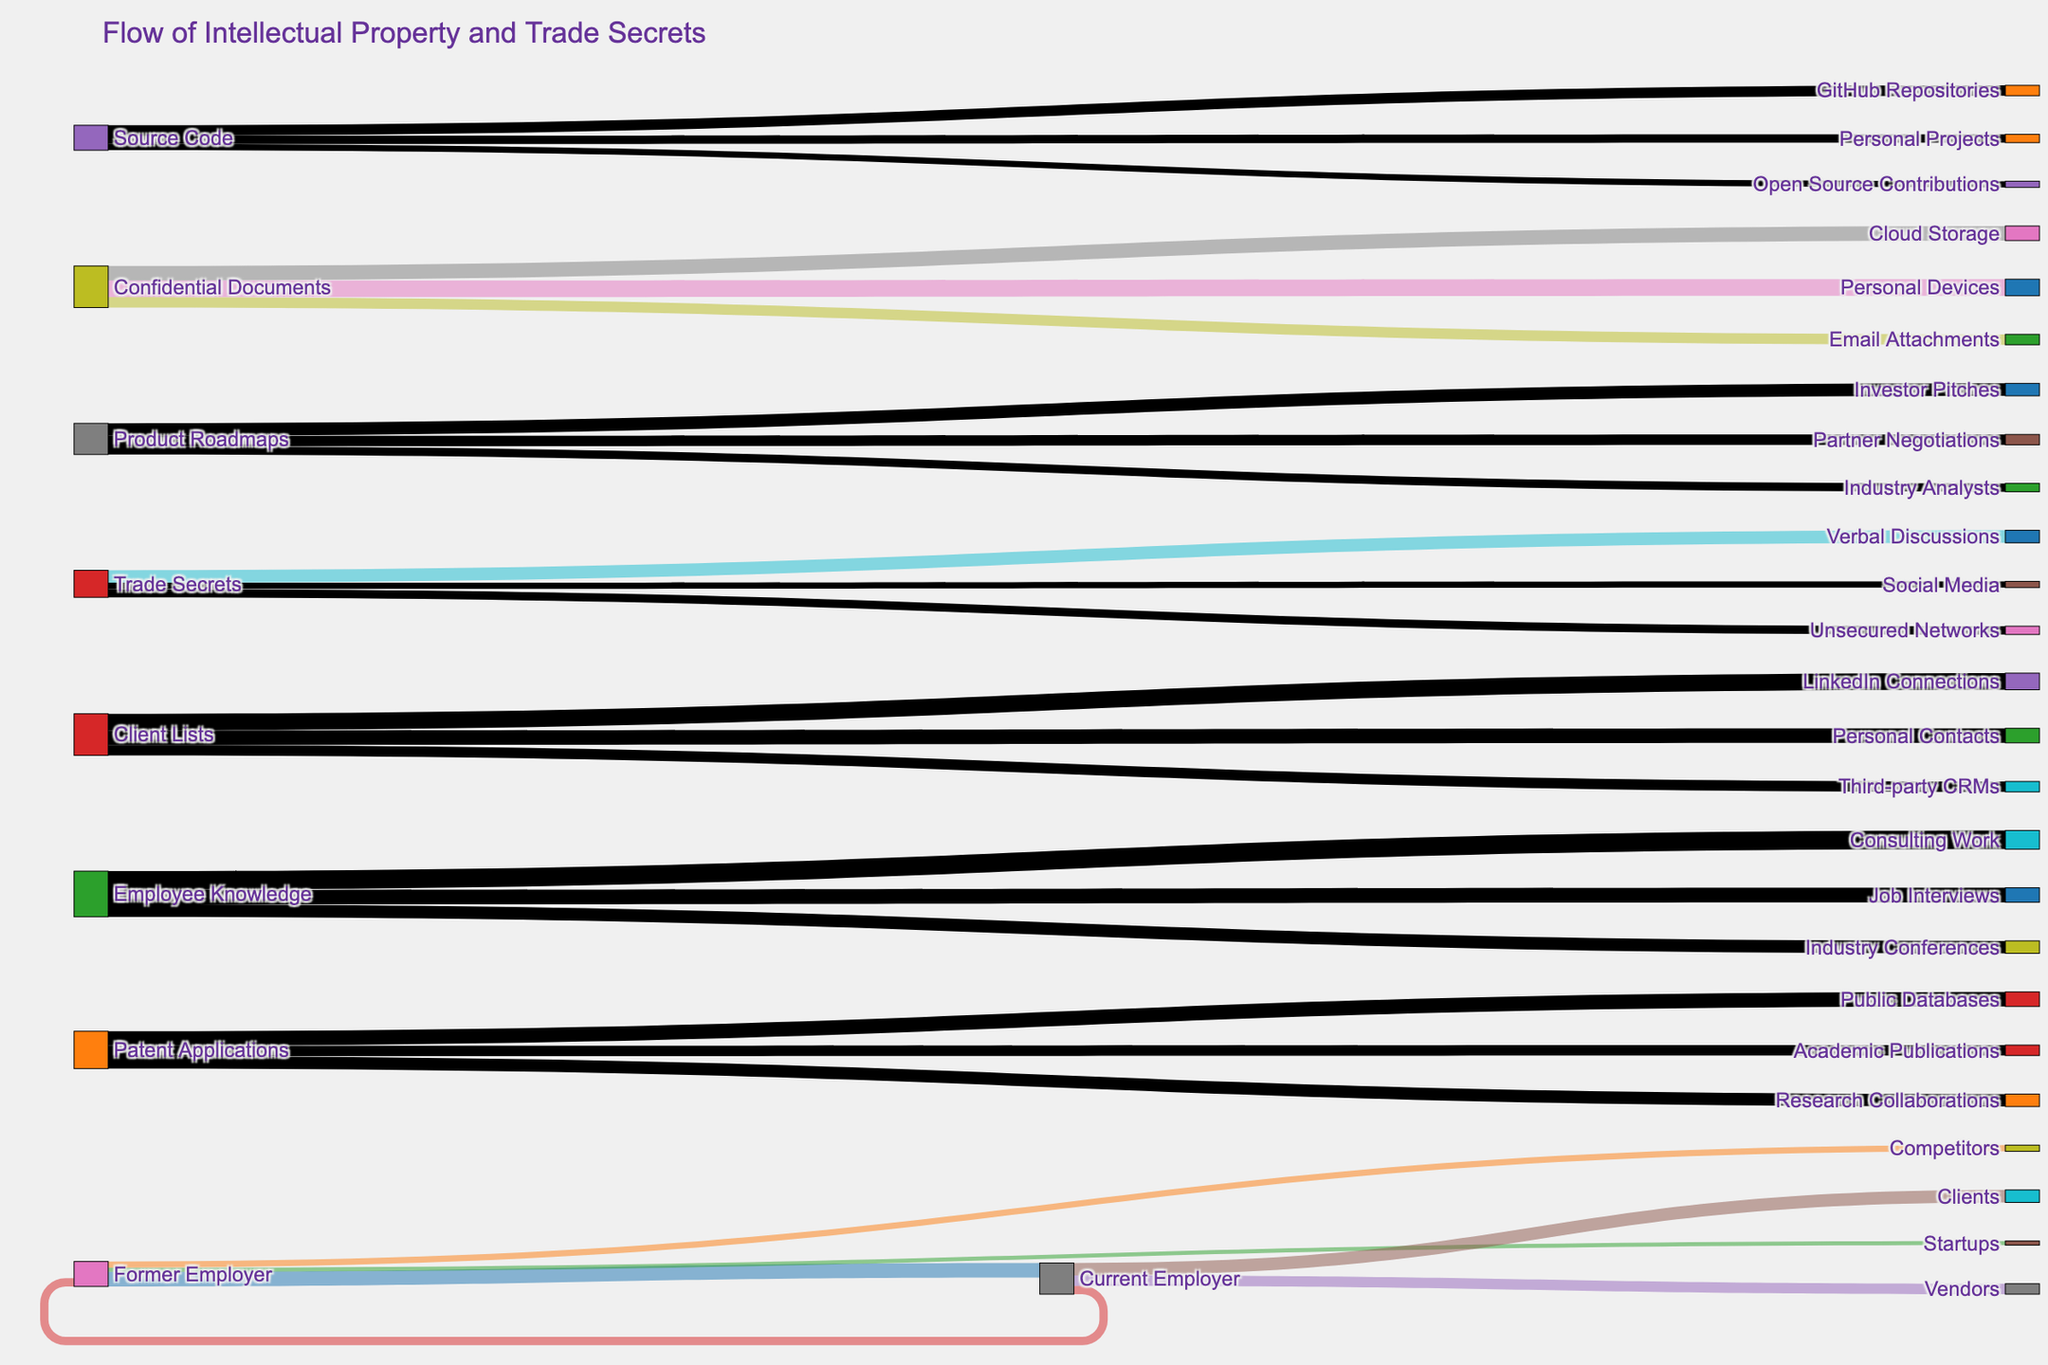Which flow has the highest value from "Former Employer"? The flows from "Former Employer" are to "Current Employer" (35), "Competitors" (15), and "Startups" (10). Comparing these values, the flow to "Current Employer" is the highest.
Answer: Flow to "Current Employer" What is the total value of flows involving "Confidential Documents"? The flows involving "Confidential Documents" are "Personal Devices" (40), "Cloud Storage" (35), and "Email Attachments" (25). Summing these values: 40 + 35 + 25 = 100.
Answer: 100 Which target has more incoming value: "LinkedIn Connections" or "Third-party CRMs"? "LinkedIn Connections" has a flow of 40 from "Client Lists" and "Third-party CRMs" has a flow of 25 from "Client Lists". Comparing these, "LinkedIn Connections" has more incoming value.
Answer: LinkedIn Connections Is the value of the flow from "Employer Knowledge" to "Job Interviews" greater than the value of the flow from "Employer Knowledge" to "Consulting Work"? The flow from "Employer Knowledge" to "Job Interviews" is 35, and to "Consulting Work" is 45. 35 is not greater than 45.
Answer: No What is the average value of the flows from "Patent Applications"? The flows from "Patent Applications" are "Public Databases" (35), "Research Collaborations" (30), and "Academic Publications" (25). The average value is (35 + 30 + 25) / 3 = 30.
Answer: 30 